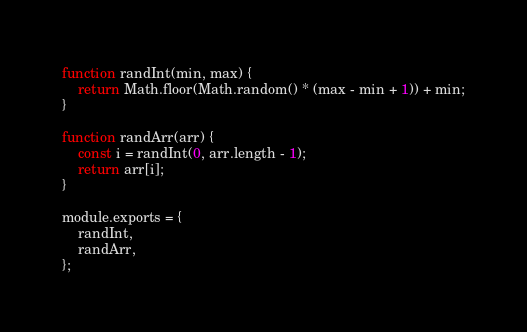Convert code to text. <code><loc_0><loc_0><loc_500><loc_500><_JavaScript_>function randInt(min, max) {
    return Math.floor(Math.random() * (max - min + 1)) + min;
}

function randArr(arr) {
    const i = randInt(0, arr.length - 1);
    return arr[i];
}

module.exports = {
    randInt,
    randArr,
};
</code> 